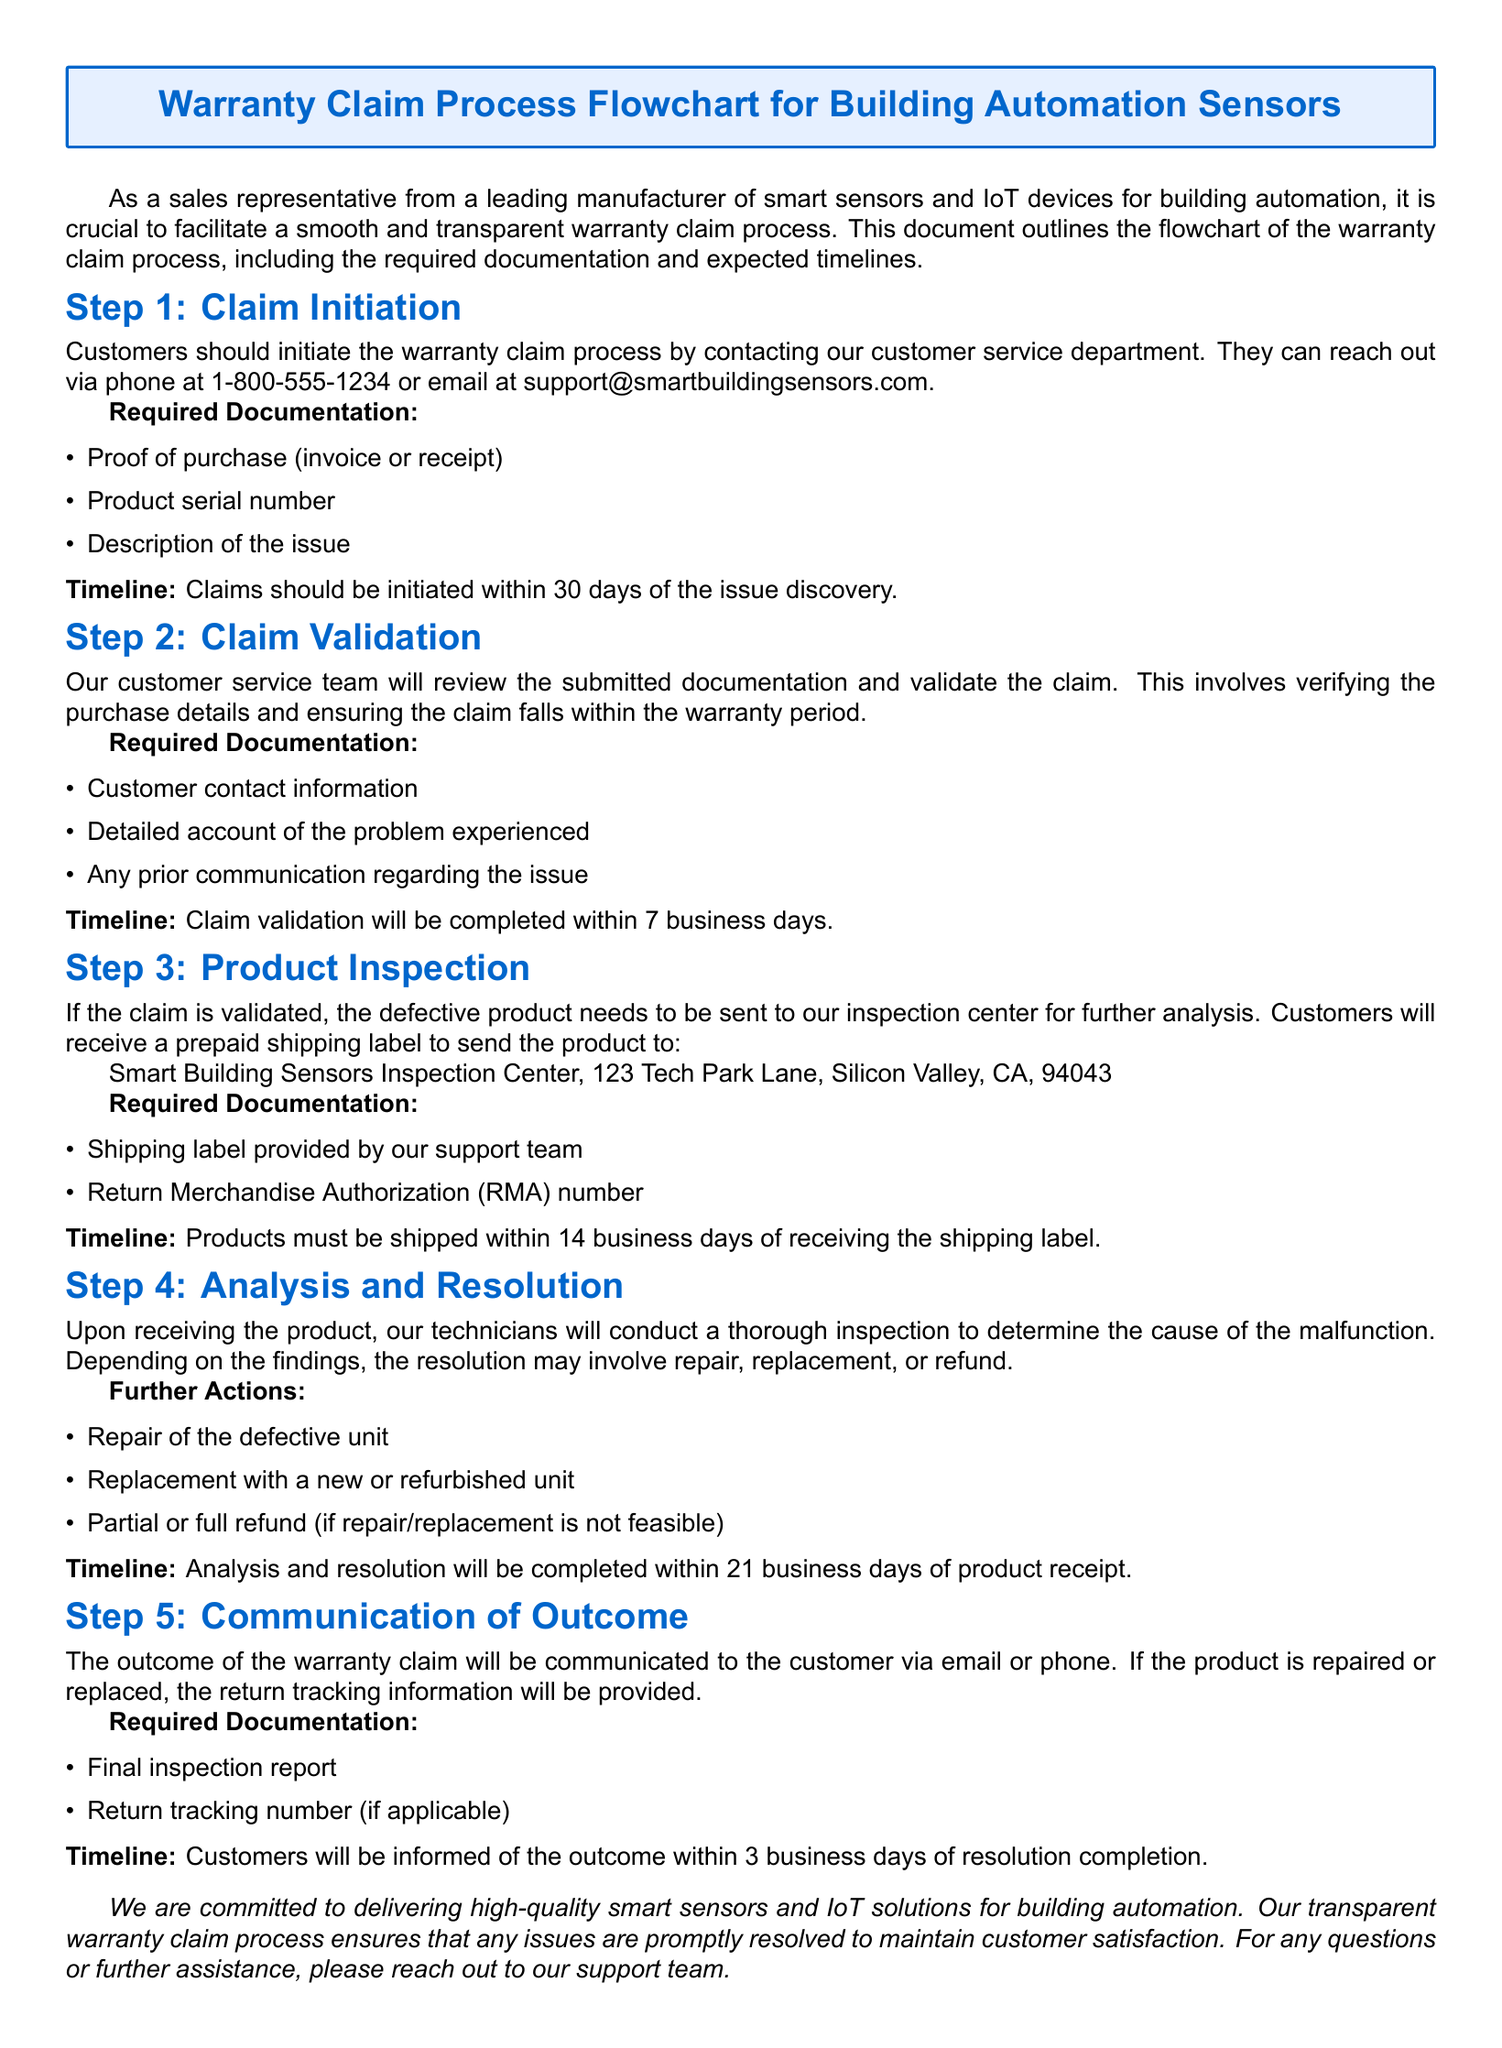What is the contact number for customer service? The contact number is listed in Step 1 of the process, which provides the necessary contact information for claim initiation.
Answer: 1-800-555-1234 What documentation is required to initiate a claim? The document specifies the required documentation for claim initiation in Step 1, listing essential items needed from customers.
Answer: Proof of purchase, product serial number, description of the issue What is the timeline for claim validation? The timeline for claim validation is detailed in Step 2 of the document, indicating the timeframe for this part of the process.
Answer: 7 business days What is the shipping timeline after receiving the shipping label? The shipping timeline after receiving the shipping label is mentioned in Step 3, providing a clear deadline for customers.
Answer: 14 business days How will the outcome of the warranty claim be communicated? The document outlines the method of communication for the outcome in Step 5, specifying how customers will be informed of the claim result.
Answer: Via email or phone What actions may be taken after product analysis? The document lists the potential resolutions after product inspection in Step 4, highlighting the different possibilities.
Answer: Repair, replacement, refund How many steps are involved in the warranty claim process? The document stages the warranty claim process clearly, indicating the total number of distinct steps from initiation to outcome communication.
Answer: 5 steps 